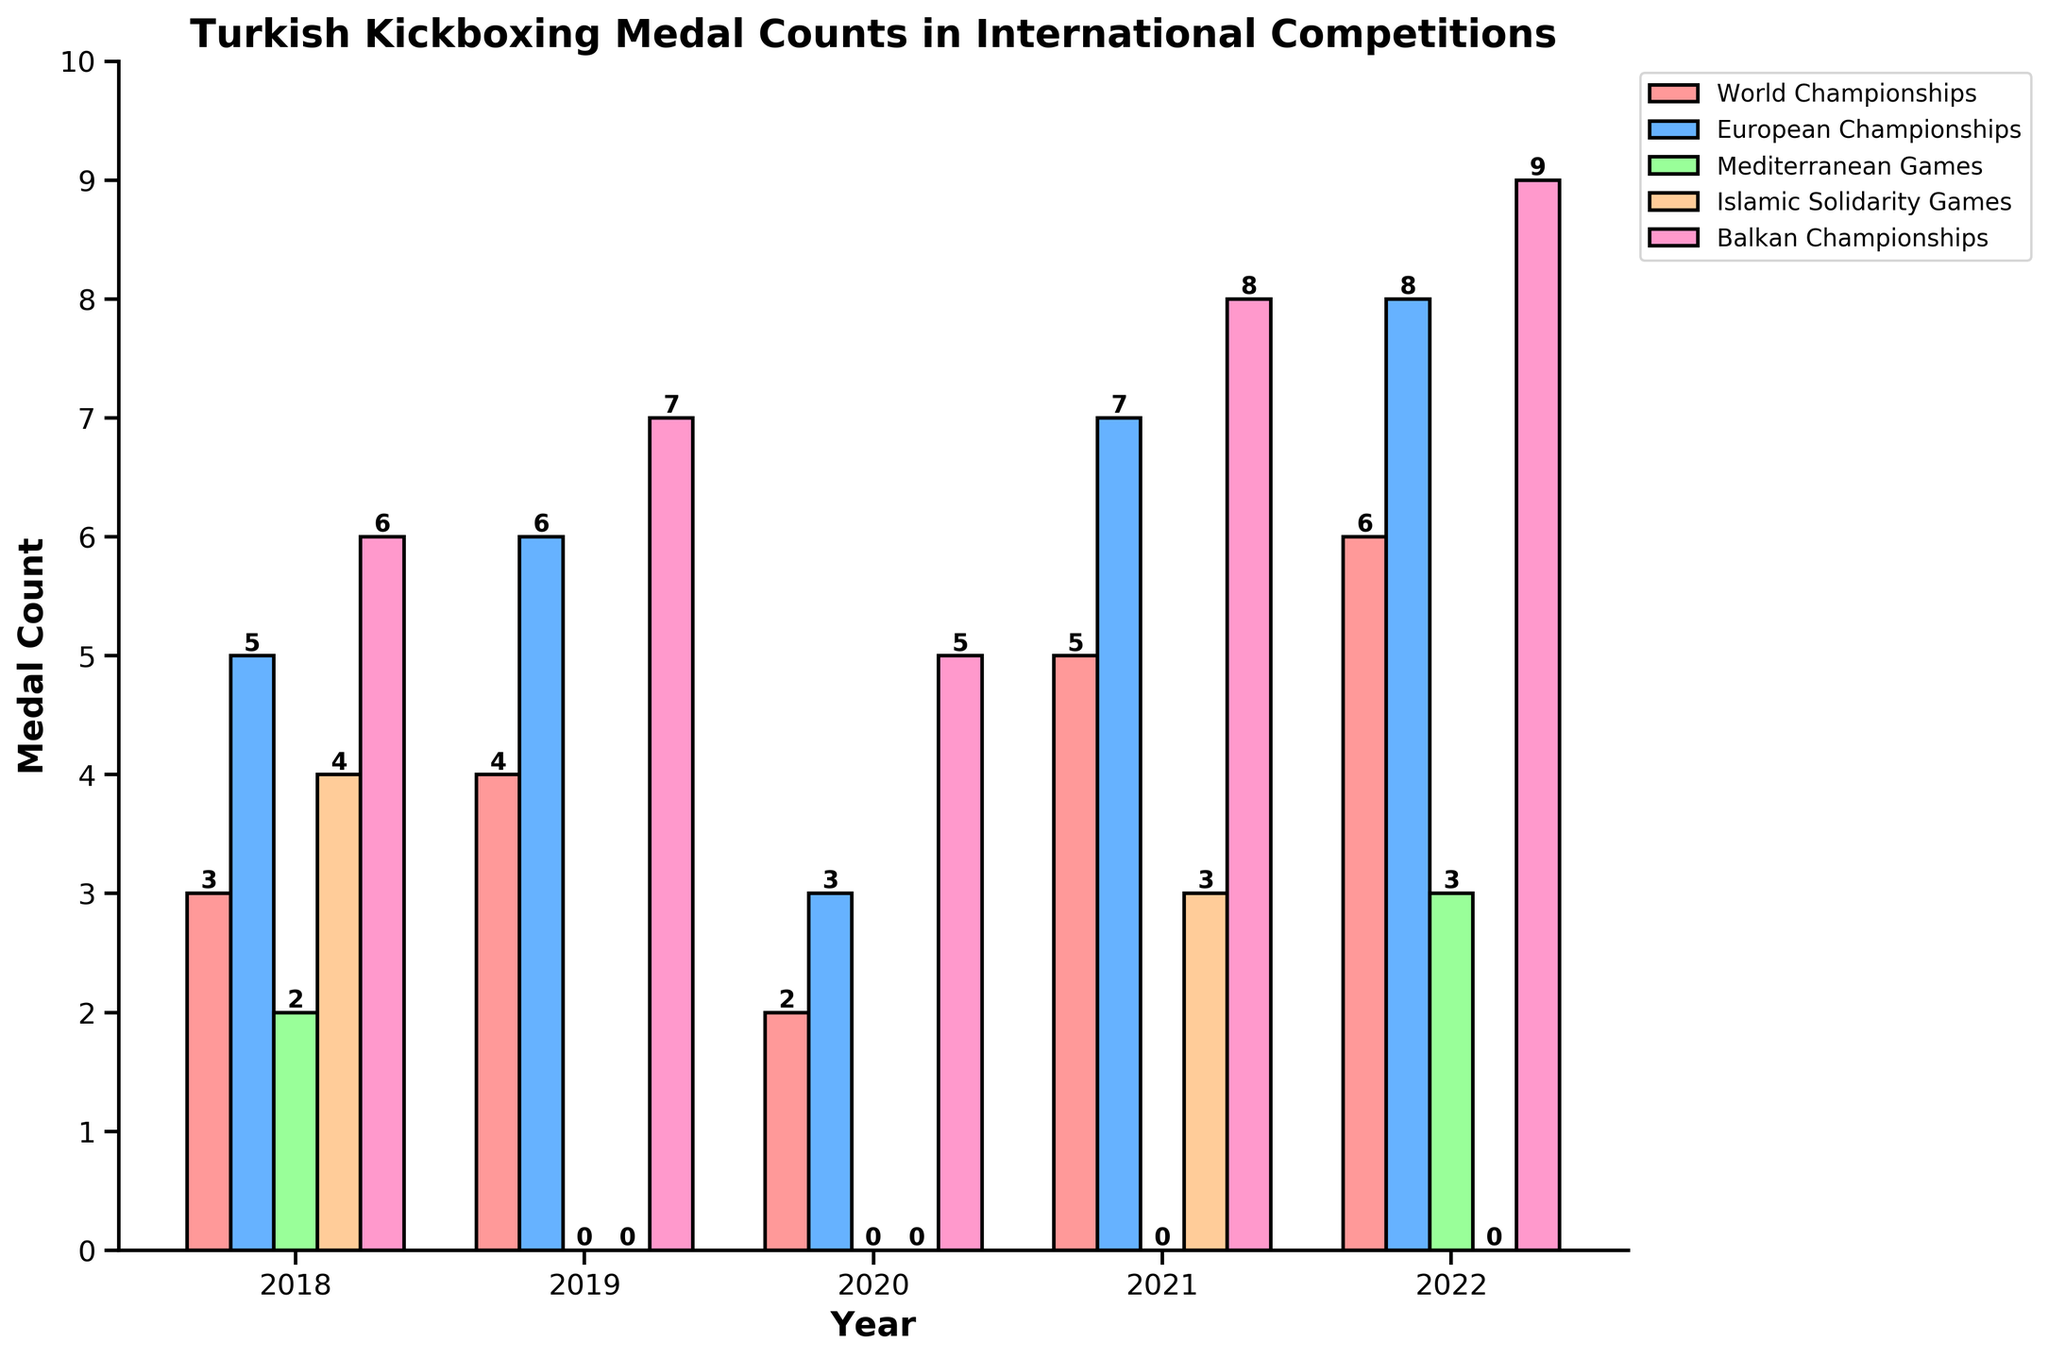Which year did Turkey win the most medals overall across all competitions? Summing the medals for each year: 2018 (3+5+2+4+6=20), 2019 (4+6+0+0+7=17), 2020 (2+3+0+0+5=10), 2021 (5+7+0+3+8=23), 2022 (6+8+3+0+9=26). The highest total is 2022 with 26 medals.
Answer: 2022 In which competition did Turkey win the most medals in 2019? The medal counts for 2019 are: World Championships (4), European Championships (6), Mediterranean Games (0), Islamic Solidarity Games (0), Balkan Championships (7). The highest is Balkan Championships with 7 medals.
Answer: Balkan Championships How many more medals did Turkey win in the European Championships in 2022 compared to 2020? The medals in the European Championships are 2022 (8) and 2020 (3). The difference is 8 - 3 = 5.
Answer: 5 Which year saw the highest number of medals in the Islamic Solidarity Games, and how many were there? Comparing the counts: 2018 (4), 2019 (0), 2020 (0), 2021 (3), 2022 (0), the highest is 2018 with 4 medals.
Answer: 2018, 4 Was there any year when Turkey did not win any medals in the Mediterranean Games? If so, which years? Checking Mediterranean Games column, years with 0 medals are 2019, 2020, 2021, and 2022.
Answer: 2019, 2020, 2021, 2022 Which competition showed the most consistent performance over the 5 years? Looking at variations: World Championships (3, 4, 2, 5, 6), European Championships (5, 6, 3, 7, 8), Mediterranean Games (2, 0, 0, 0, 3), Islamic Solidarity Games (4, 0, 0, 3, 0), Balkan Championships (6, 7, 5, 8, 9). Balkan Championships has the smallest range of fluctuation growths consistently each year.
Answer: Balkan Championships In 2022, how did Turkey's medal count in the Balkan Championships compare to its total medal count in 2020? Balkan Championships 2022 had 9 medals; Total in 2020 is 10 medals. Hence, 9 is close to the total of 2020.
Answer: 1 less Which year had the lowest overall number of medals, and what was the count? Summing the medals for each year: 2018 (20), 2019 (17), 2020 (10), 2021 (23), 2022 (26). The lowest total is 2020 with 10 medals.
Answer: 2020, 10 